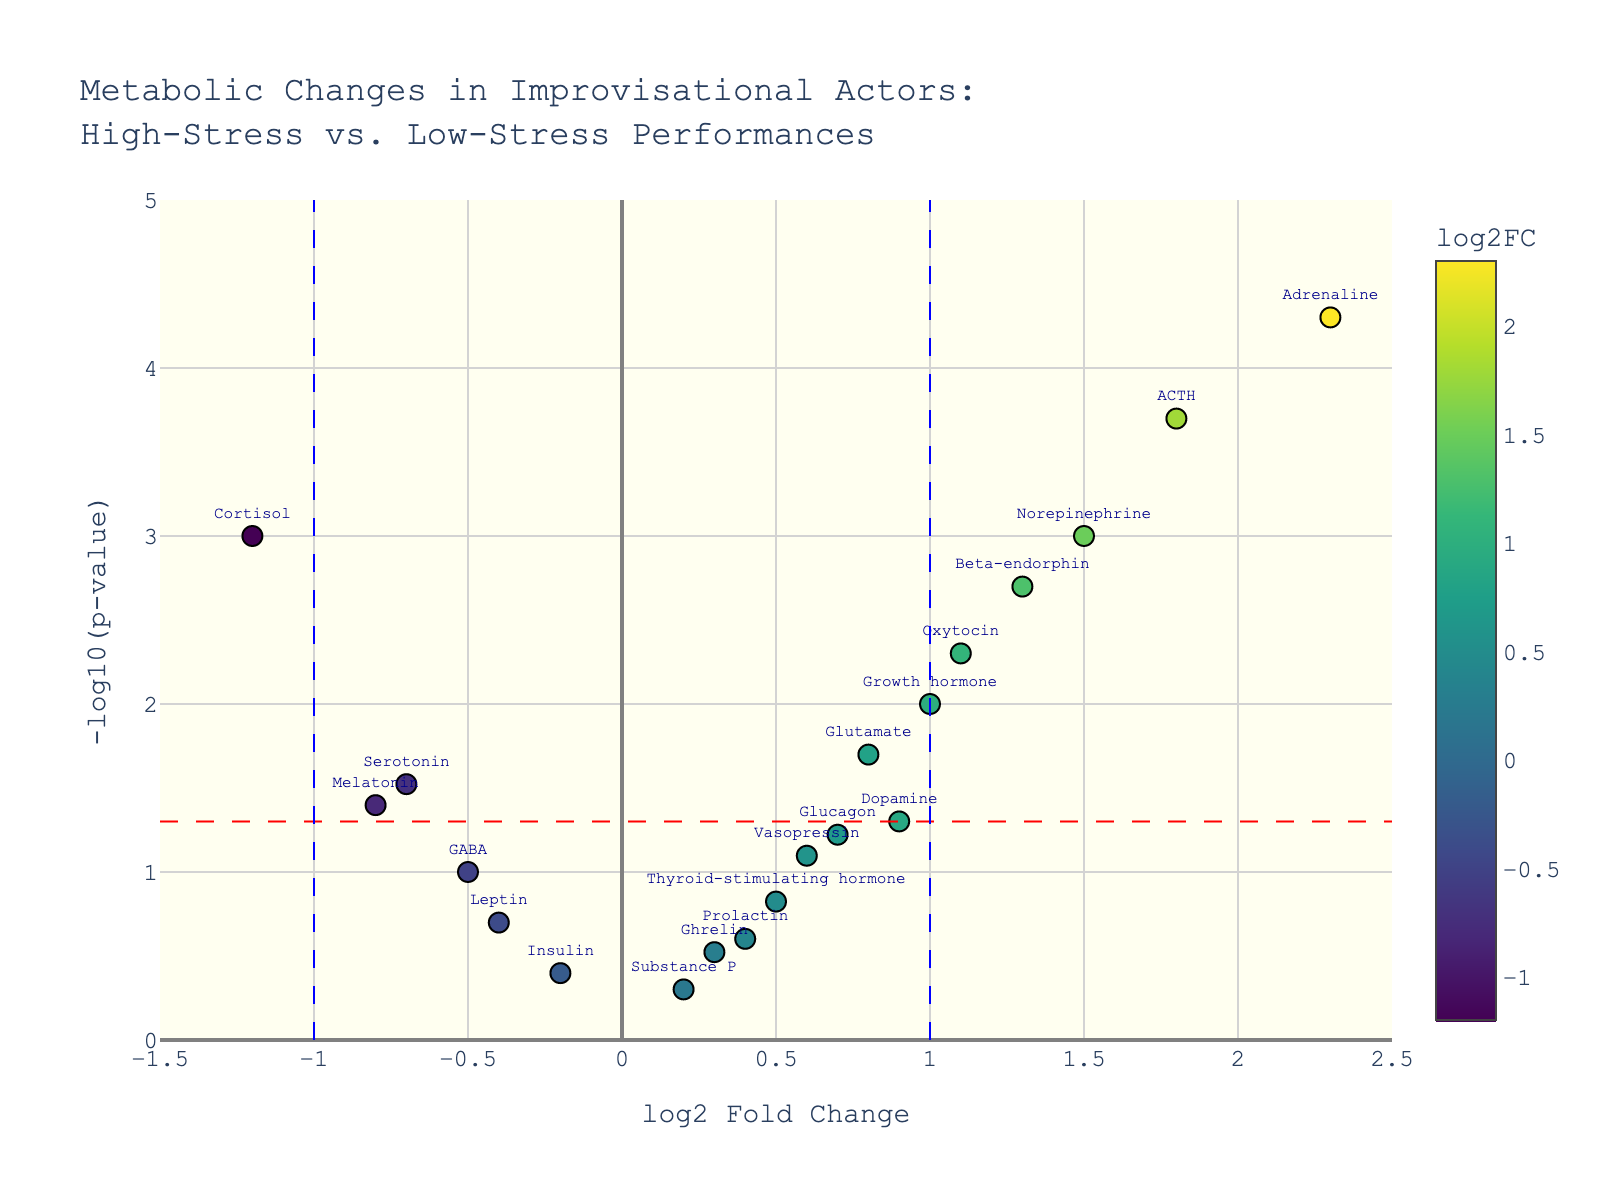What's the title of the plot? The title of the plot is usually located at the top of the figure; in this case, it's written in a distinctive font.
Answer: Metabolic Changes in Improvisational Actors: High-Stress vs. Low-Stress Performances How many data points are shown in the plot? Count the individual markers on the plot. Each marker represents a data point, and their total count equals the number of data points.
Answer: 20 What does the x-axis represent? Look at the label on the x-axis, which should be described clearly.
Answer: log2 Fold Change Which axis shows the statistical significance of the genes, and how is it represented? Examine the label on the y-axis. The axis representing statistical significance shows a transformation of the p-value.
Answer: y-axis, represented as -log10(p-value) Which gene has the highest log2 fold change? By examining the x-axis values, identify the marker farthest to the right.
Answer: Adrenaline Which genes have a log2 fold change greater than 1 and are statistically significant (p-value < 0.05)? Identify markers to the right of the vertical line (x > 1) and above the horizontal line corresponding to -log10(0.05). Look at the text labels of these markers.
Answer: Adrenaline, ACTH, Oxytocin, Beta-endorphin Is dopamine considered statistically significant in this plot? Check if Dopamine is located above the horizontal line indicating -log10(0.05).
Answer: No What is the log2 fold change of cortisol, and what does its direction indicate in terms of metabolic changes? Look for the marker labeled Cortisol and note its x-axis position. Compare the value with the vertical lines to understand its direction.
Answer: -1.2, indicating a decrease Which gene has the smallest p-value, and how do you know? Find the marker positioned highest on the y-axis as -log10(p-value) is plotted, so the highest point means the smallest p-value. Look at its label.
Answer: Adrenaline 